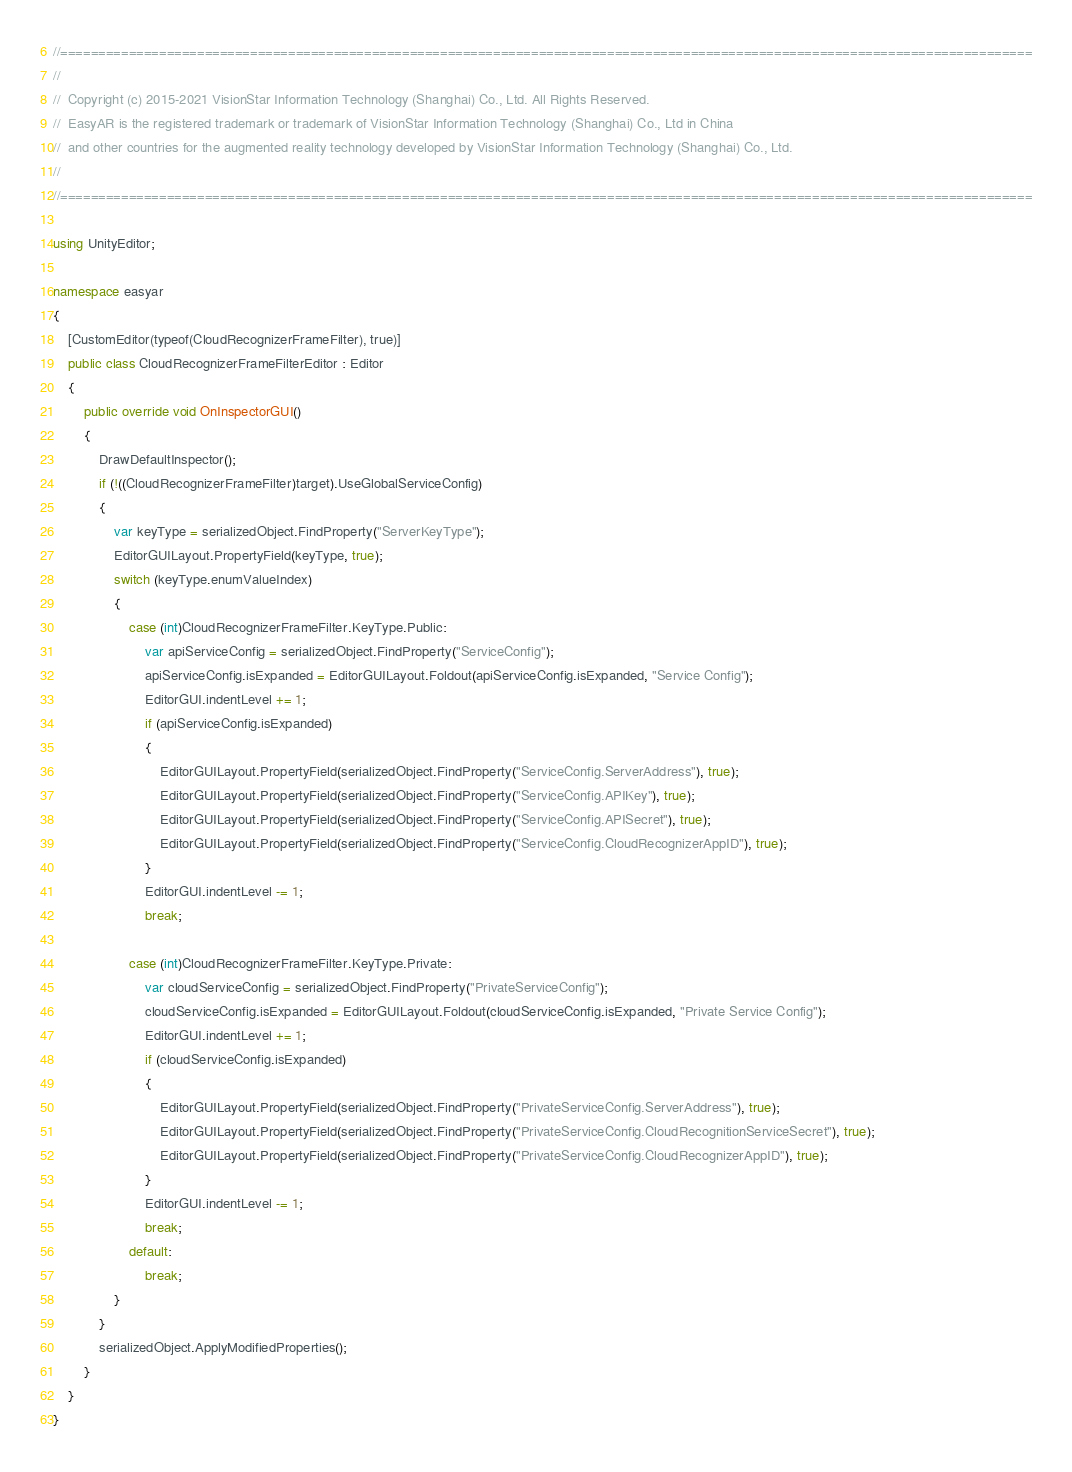<code> <loc_0><loc_0><loc_500><loc_500><_C#_>//================================================================================================================================
//
//  Copyright (c) 2015-2021 VisionStar Information Technology (Shanghai) Co., Ltd. All Rights Reserved.
//  EasyAR is the registered trademark or trademark of VisionStar Information Technology (Shanghai) Co., Ltd in China
//  and other countries for the augmented reality technology developed by VisionStar Information Technology (Shanghai) Co., Ltd.
//
//================================================================================================================================

using UnityEditor;

namespace easyar
{
    [CustomEditor(typeof(CloudRecognizerFrameFilter), true)]
    public class CloudRecognizerFrameFilterEditor : Editor
    {
        public override void OnInspectorGUI()
        {
            DrawDefaultInspector();
            if (!((CloudRecognizerFrameFilter)target).UseGlobalServiceConfig)
            {
                var keyType = serializedObject.FindProperty("ServerKeyType");
                EditorGUILayout.PropertyField(keyType, true);
                switch (keyType.enumValueIndex)
                {
                    case (int)CloudRecognizerFrameFilter.KeyType.Public:
                        var apiServiceConfig = serializedObject.FindProperty("ServiceConfig");
                        apiServiceConfig.isExpanded = EditorGUILayout.Foldout(apiServiceConfig.isExpanded, "Service Config");
                        EditorGUI.indentLevel += 1;
                        if (apiServiceConfig.isExpanded)
                        {
                            EditorGUILayout.PropertyField(serializedObject.FindProperty("ServiceConfig.ServerAddress"), true);
                            EditorGUILayout.PropertyField(serializedObject.FindProperty("ServiceConfig.APIKey"), true);
                            EditorGUILayout.PropertyField(serializedObject.FindProperty("ServiceConfig.APISecret"), true);
                            EditorGUILayout.PropertyField(serializedObject.FindProperty("ServiceConfig.CloudRecognizerAppID"), true);
                        }
                        EditorGUI.indentLevel -= 1;
                        break;

                    case (int)CloudRecognizerFrameFilter.KeyType.Private:
                        var cloudServiceConfig = serializedObject.FindProperty("PrivateServiceConfig");
                        cloudServiceConfig.isExpanded = EditorGUILayout.Foldout(cloudServiceConfig.isExpanded, "Private Service Config");
                        EditorGUI.indentLevel += 1;
                        if (cloudServiceConfig.isExpanded)
                        {
                            EditorGUILayout.PropertyField(serializedObject.FindProperty("PrivateServiceConfig.ServerAddress"), true);
                            EditorGUILayout.PropertyField(serializedObject.FindProperty("PrivateServiceConfig.CloudRecognitionServiceSecret"), true);
                            EditorGUILayout.PropertyField(serializedObject.FindProperty("PrivateServiceConfig.CloudRecognizerAppID"), true);
                        }
                        EditorGUI.indentLevel -= 1;
                        break;
                    default:
                        break;
                }
            }
            serializedObject.ApplyModifiedProperties();
        }
    }
}
</code> 